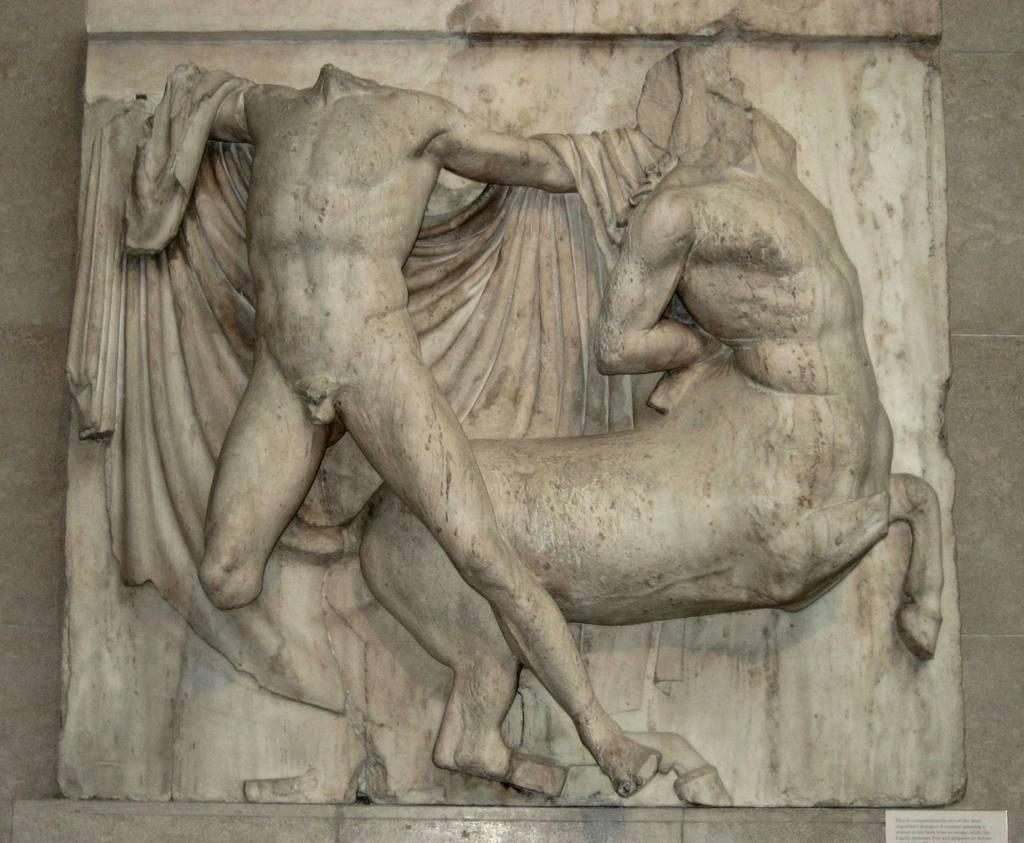What is depicted on the wall in the image? There are sculptures on the wall in the image. Is there any text present in the image? Yes, there is text at the bottom of the image. How does the dirt affect the science experiment in the image? There is no dirt or science experiment present in the image; it features sculptures on the wall and text at the bottom. What type of volleyball is being played in the image? There is no volleyball or any sports-related activity depicted in the image. 